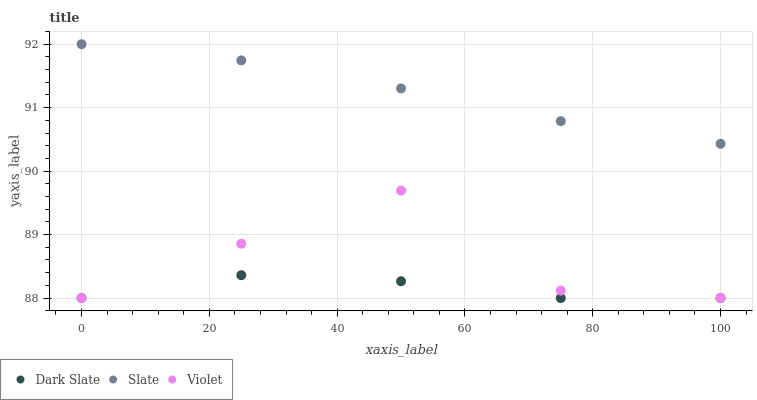Does Dark Slate have the minimum area under the curve?
Answer yes or no. Yes. Does Slate have the maximum area under the curve?
Answer yes or no. Yes. Does Violet have the minimum area under the curve?
Answer yes or no. No. Does Violet have the maximum area under the curve?
Answer yes or no. No. Is Slate the smoothest?
Answer yes or no. Yes. Is Violet the roughest?
Answer yes or no. Yes. Is Violet the smoothest?
Answer yes or no. No. Is Slate the roughest?
Answer yes or no. No. Does Dark Slate have the lowest value?
Answer yes or no. Yes. Does Slate have the lowest value?
Answer yes or no. No. Does Slate have the highest value?
Answer yes or no. Yes. Does Violet have the highest value?
Answer yes or no. No. Is Dark Slate less than Slate?
Answer yes or no. Yes. Is Slate greater than Dark Slate?
Answer yes or no. Yes. Does Dark Slate intersect Violet?
Answer yes or no. Yes. Is Dark Slate less than Violet?
Answer yes or no. No. Is Dark Slate greater than Violet?
Answer yes or no. No. Does Dark Slate intersect Slate?
Answer yes or no. No. 